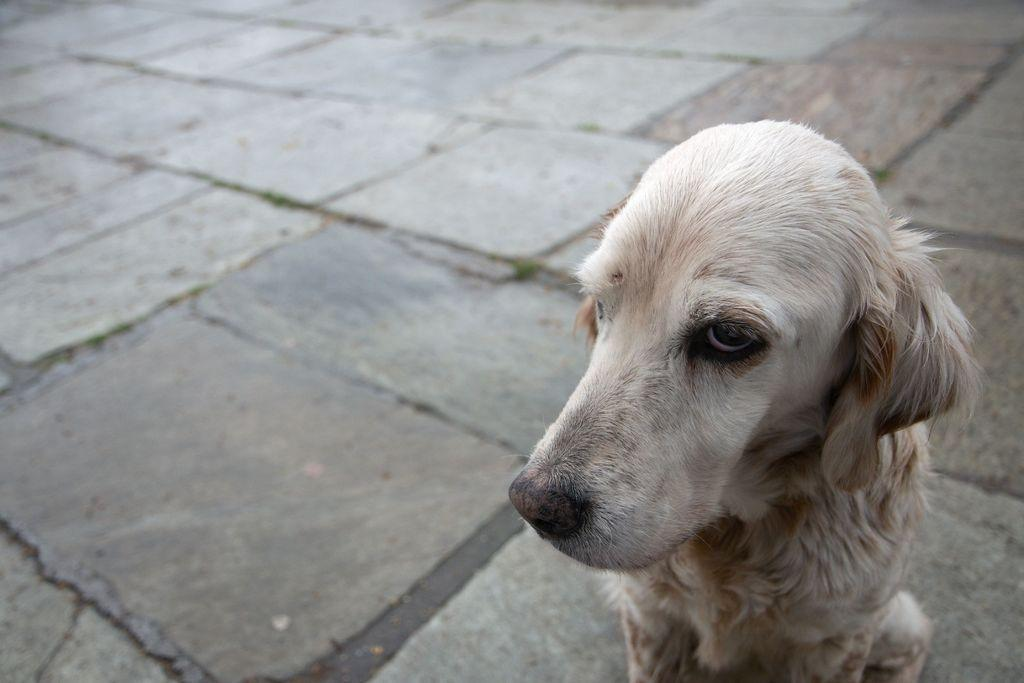What type of animal is present in the image? There is a dog in the image. Where is the dog located in the image? The dog is sitting on the floor. What role does the dog's mom play in the committee meeting in the image? There is no committee meeting or dog's mom present in the image. 